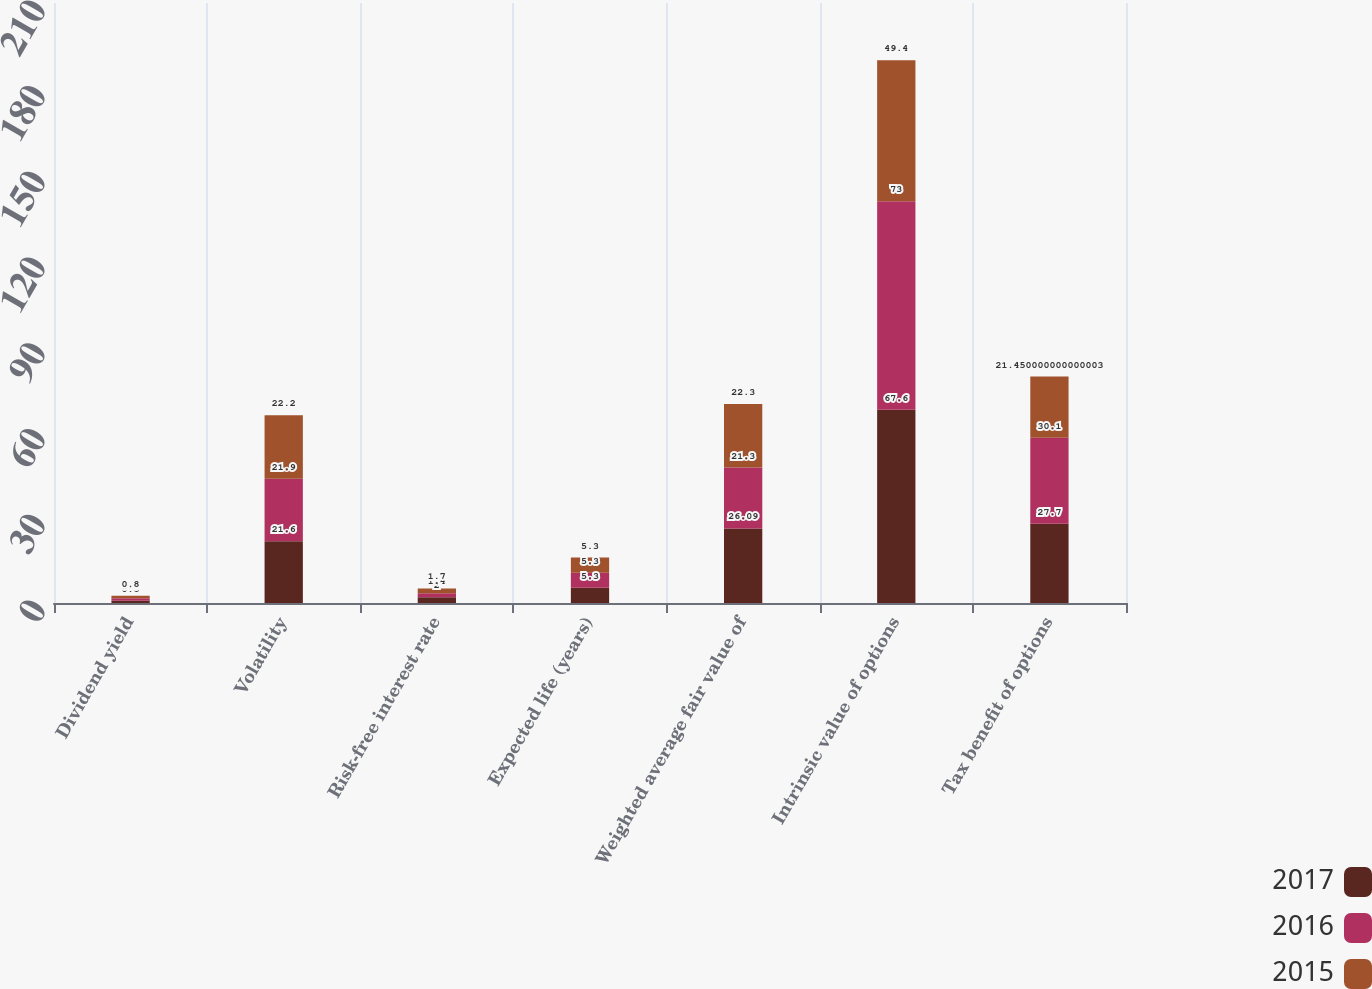<chart> <loc_0><loc_0><loc_500><loc_500><stacked_bar_chart><ecel><fcel>Dividend yield<fcel>Volatility<fcel>Risk-free interest rate<fcel>Expected life (years)<fcel>Weighted average fair value of<fcel>Intrinsic value of options<fcel>Tax benefit of options<nl><fcel>2017<fcel>0.8<fcel>21.6<fcel>2<fcel>5.3<fcel>26.09<fcel>67.6<fcel>27.7<nl><fcel>2016<fcel>0.9<fcel>21.9<fcel>1.4<fcel>5.3<fcel>21.3<fcel>73<fcel>30.1<nl><fcel>2015<fcel>0.8<fcel>22.2<fcel>1.7<fcel>5.3<fcel>22.3<fcel>49.4<fcel>21.45<nl></chart> 